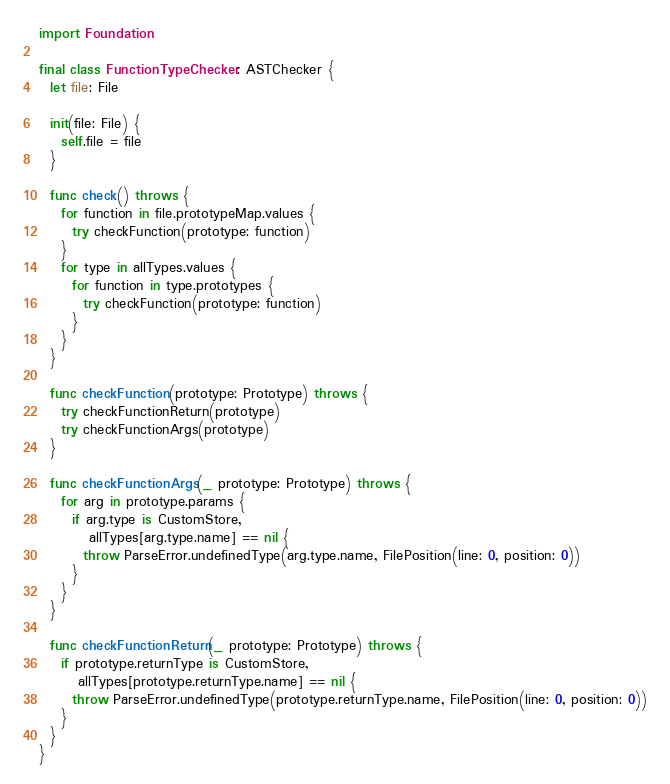<code> <loc_0><loc_0><loc_500><loc_500><_Swift_>
import Foundation

final class FunctionTypeChecker: ASTChecker {
  let file: File
  
  init(file: File) {
    self.file = file
  }
  
  func check() throws {
    for function in file.prototypeMap.values {
      try checkFunction(prototype: function)
    }
    for type in allTypes.values {
      for function in type.prototypes {
        try checkFunction(prototype: function)
      }
    }
  }
  
  func checkFunction(prototype: Prototype) throws {
    try checkFunctionReturn(prototype)
    try checkFunctionArgs(prototype)
  }
  
  func checkFunctionArgs(_ prototype: Prototype) throws {
    for arg in prototype.params {
      if arg.type is CustomStore,
         allTypes[arg.type.name] == nil {
        throw ParseError.undefinedType(arg.type.name, FilePosition(line: 0, position: 0))
      }
    }
  }
  
  func checkFunctionReturn(_ prototype: Prototype) throws {
    if prototype.returnType is CustomStore,
       allTypes[prototype.returnType.name] == nil {
      throw ParseError.undefinedType(prototype.returnType.name, FilePosition(line: 0, position: 0))
    }
  }
}
</code> 